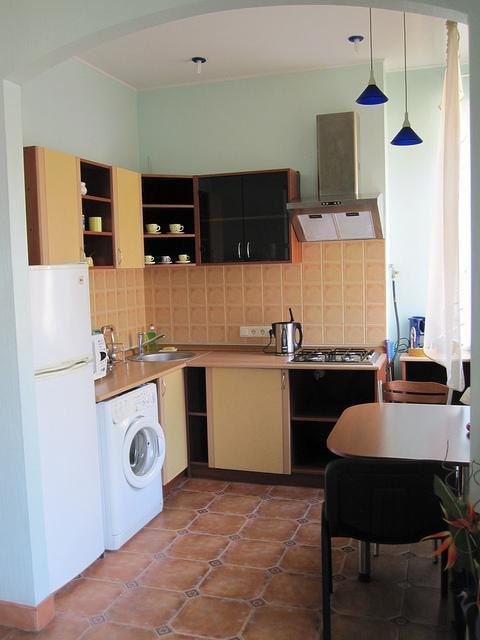What is the small white appliance?
Select the correct answer and articulate reasoning with the following format: 'Answer: answer
Rationale: rationale.'
Options: Stove, refrigerator, dishwasher, clothes washer. Answer: clothes washer.
Rationale: The small white appliance next to the refrigerator is used for washing clothes. Which appliance sits right next to the refrigerator?
Indicate the correct response by choosing from the four available options to answer the question.
Options: Washing machine, oven, dishwasher, sink. Washing machine. 